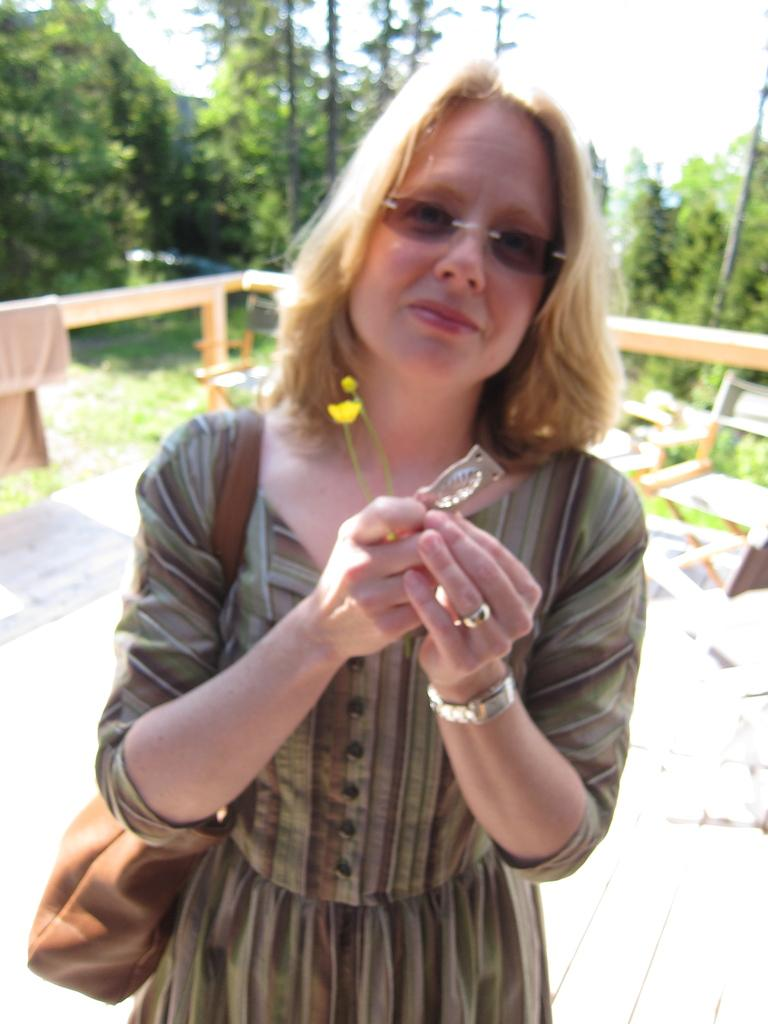What is the primary subject of the image? There is a woman in the image. What is the woman wearing? The woman is wearing a bag. What is the woman holding in her hand? The woman is holding an object in her hand. Can you describe the cloth in the image? There is a cloth on a wooden object. What can be seen in the background of the image? There are trees in the background of the image. What type of cheese is being sliced by the blade in the image? There is no cheese or blade present in the image. What hope does the woman have for the future in the image? The image does not provide any information about the woman's hopes for the future. 